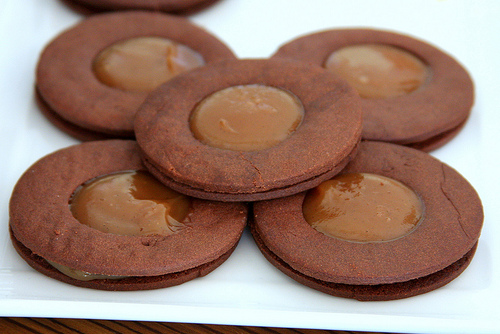<image>
Can you confirm if the cream is on the plate? No. The cream is not positioned on the plate. They may be near each other, but the cream is not supported by or resting on top of the plate. 